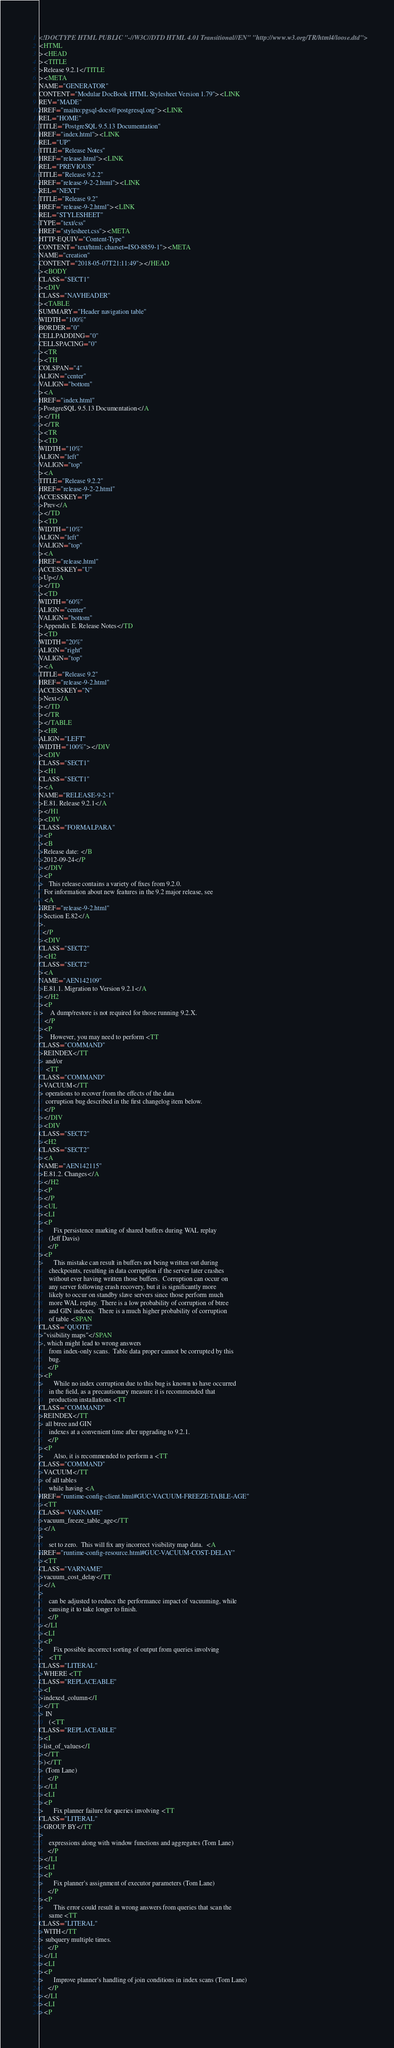<code> <loc_0><loc_0><loc_500><loc_500><_HTML_><!DOCTYPE HTML PUBLIC "-//W3C//DTD HTML 4.01 Transitional//EN" "http://www.w3.org/TR/html4/loose.dtd">
<HTML
><HEAD
><TITLE
>Release 9.2.1</TITLE
><META
NAME="GENERATOR"
CONTENT="Modular DocBook HTML Stylesheet Version 1.79"><LINK
REV="MADE"
HREF="mailto:pgsql-docs@postgresql.org"><LINK
REL="HOME"
TITLE="PostgreSQL 9.5.13 Documentation"
HREF="index.html"><LINK
REL="UP"
TITLE="Release Notes"
HREF="release.html"><LINK
REL="PREVIOUS"
TITLE="Release 9.2.2"
HREF="release-9-2-2.html"><LINK
REL="NEXT"
TITLE="Release 9.2"
HREF="release-9-2.html"><LINK
REL="STYLESHEET"
TYPE="text/css"
HREF="stylesheet.css"><META
HTTP-EQUIV="Content-Type"
CONTENT="text/html; charset=ISO-8859-1"><META
NAME="creation"
CONTENT="2018-05-07T21:11:49"></HEAD
><BODY
CLASS="SECT1"
><DIV
CLASS="NAVHEADER"
><TABLE
SUMMARY="Header navigation table"
WIDTH="100%"
BORDER="0"
CELLPADDING="0"
CELLSPACING="0"
><TR
><TH
COLSPAN="4"
ALIGN="center"
VALIGN="bottom"
><A
HREF="index.html"
>PostgreSQL 9.5.13 Documentation</A
></TH
></TR
><TR
><TD
WIDTH="10%"
ALIGN="left"
VALIGN="top"
><A
TITLE="Release 9.2.2"
HREF="release-9-2-2.html"
ACCESSKEY="P"
>Prev</A
></TD
><TD
WIDTH="10%"
ALIGN="left"
VALIGN="top"
><A
HREF="release.html"
ACCESSKEY="U"
>Up</A
></TD
><TD
WIDTH="60%"
ALIGN="center"
VALIGN="bottom"
>Appendix E. Release Notes</TD
><TD
WIDTH="20%"
ALIGN="right"
VALIGN="top"
><A
TITLE="Release 9.2"
HREF="release-9-2.html"
ACCESSKEY="N"
>Next</A
></TD
></TR
></TABLE
><HR
ALIGN="LEFT"
WIDTH="100%"></DIV
><DIV
CLASS="SECT1"
><H1
CLASS="SECT1"
><A
NAME="RELEASE-9-2-1"
>E.81. Release 9.2.1</A
></H1
><DIV
CLASS="FORMALPARA"
><P
><B
>Release date: </B
>2012-09-24</P
></DIV
><P
>   This release contains a variety of fixes from 9.2.0.
   For information about new features in the 9.2 major release, see
   <A
HREF="release-9-2.html"
>Section E.82</A
>.
  </P
><DIV
CLASS="SECT2"
><H2
CLASS="SECT2"
><A
NAME="AEN142109"
>E.81.1. Migration to Version 9.2.1</A
></H2
><P
>    A dump/restore is not required for those running 9.2.X.
   </P
><P
>    However, you may need to perform <TT
CLASS="COMMAND"
>REINDEX</TT
> and/or
    <TT
CLASS="COMMAND"
>VACUUM</TT
> operations to recover from the effects of the data
    corruption bug described in the first changelog item below.
   </P
></DIV
><DIV
CLASS="SECT2"
><H2
CLASS="SECT2"
><A
NAME="AEN142115"
>E.81.2. Changes</A
></H2
><P
></P
><UL
><LI
><P
>      Fix persistence marking of shared buffers during WAL replay
      (Jeff Davis)
     </P
><P
>      This mistake can result in buffers not being written out during
      checkpoints, resulting in data corruption if the server later crashes
      without ever having written those buffers.  Corruption can occur on
      any server following crash recovery, but it is significantly more
      likely to occur on standby slave servers since those perform much
      more WAL replay.  There is a low probability of corruption of btree
      and GIN indexes.  There is a much higher probability of corruption
      of table <SPAN
CLASS="QUOTE"
>"visibility maps"</SPAN
>, which might lead to wrong answers
      from index-only scans.  Table data proper cannot be corrupted by this
      bug.
     </P
><P
>      While no index corruption due to this bug is known to have occurred
      in the field, as a precautionary measure it is recommended that
      production installations <TT
CLASS="COMMAND"
>REINDEX</TT
> all btree and GIN
      indexes at a convenient time after upgrading to 9.2.1.
     </P
><P
>      Also, it is recommended to perform a <TT
CLASS="COMMAND"
>VACUUM</TT
> of all tables
      while having <A
HREF="runtime-config-client.html#GUC-VACUUM-FREEZE-TABLE-AGE"
><TT
CLASS="VARNAME"
>vacuum_freeze_table_age</TT
></A
>
      set to zero.  This will fix any incorrect visibility map data.  <A
HREF="runtime-config-resource.html#GUC-VACUUM-COST-DELAY"
><TT
CLASS="VARNAME"
>vacuum_cost_delay</TT
></A
>
      can be adjusted to reduce the performance impact of vacuuming, while
      causing it to take longer to finish.
     </P
></LI
><LI
><P
>      Fix possible incorrect sorting of output from queries involving
      <TT
CLASS="LITERAL"
>WHERE <TT
CLASS="REPLACEABLE"
><I
>indexed_column</I
></TT
> IN
      (<TT
CLASS="REPLACEABLE"
><I
>list_of_values</I
></TT
>)</TT
> (Tom Lane)
     </P
></LI
><LI
><P
>      Fix planner failure for queries involving <TT
CLASS="LITERAL"
>GROUP BY</TT
>
      expressions along with window functions and aggregates (Tom Lane)
     </P
></LI
><LI
><P
>      Fix planner's assignment of executor parameters (Tom Lane)
     </P
><P
>      This error could result in wrong answers from queries that scan the
      same <TT
CLASS="LITERAL"
>WITH</TT
> subquery multiple times.
     </P
></LI
><LI
><P
>      Improve planner's handling of join conditions in index scans (Tom Lane)
     </P
></LI
><LI
><P</code> 